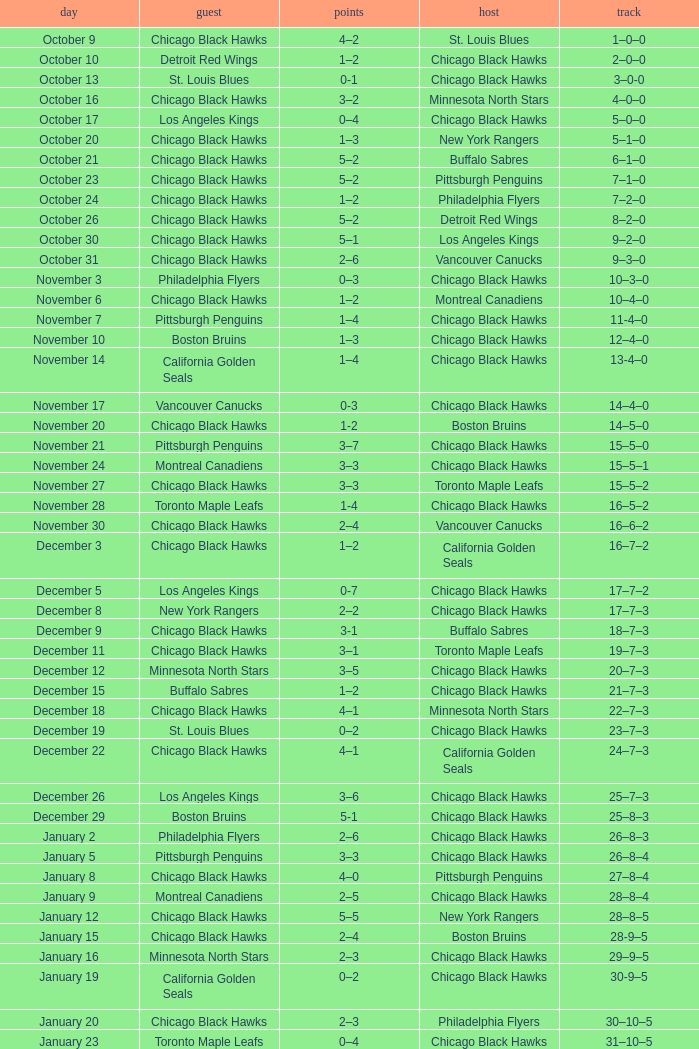Can you provide the score from the november 17th home game between the chicago black hawks and the vancouver canucks? 0-3. 